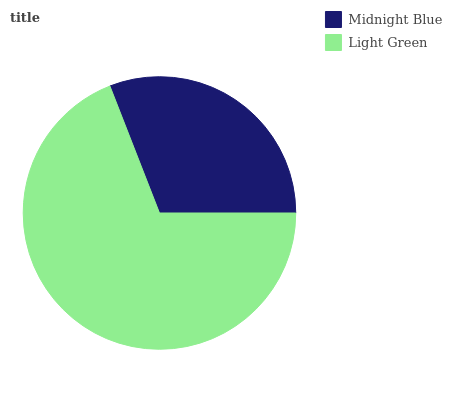Is Midnight Blue the minimum?
Answer yes or no. Yes. Is Light Green the maximum?
Answer yes or no. Yes. Is Light Green the minimum?
Answer yes or no. No. Is Light Green greater than Midnight Blue?
Answer yes or no. Yes. Is Midnight Blue less than Light Green?
Answer yes or no. Yes. Is Midnight Blue greater than Light Green?
Answer yes or no. No. Is Light Green less than Midnight Blue?
Answer yes or no. No. Is Light Green the high median?
Answer yes or no. Yes. Is Midnight Blue the low median?
Answer yes or no. Yes. Is Midnight Blue the high median?
Answer yes or no. No. Is Light Green the low median?
Answer yes or no. No. 